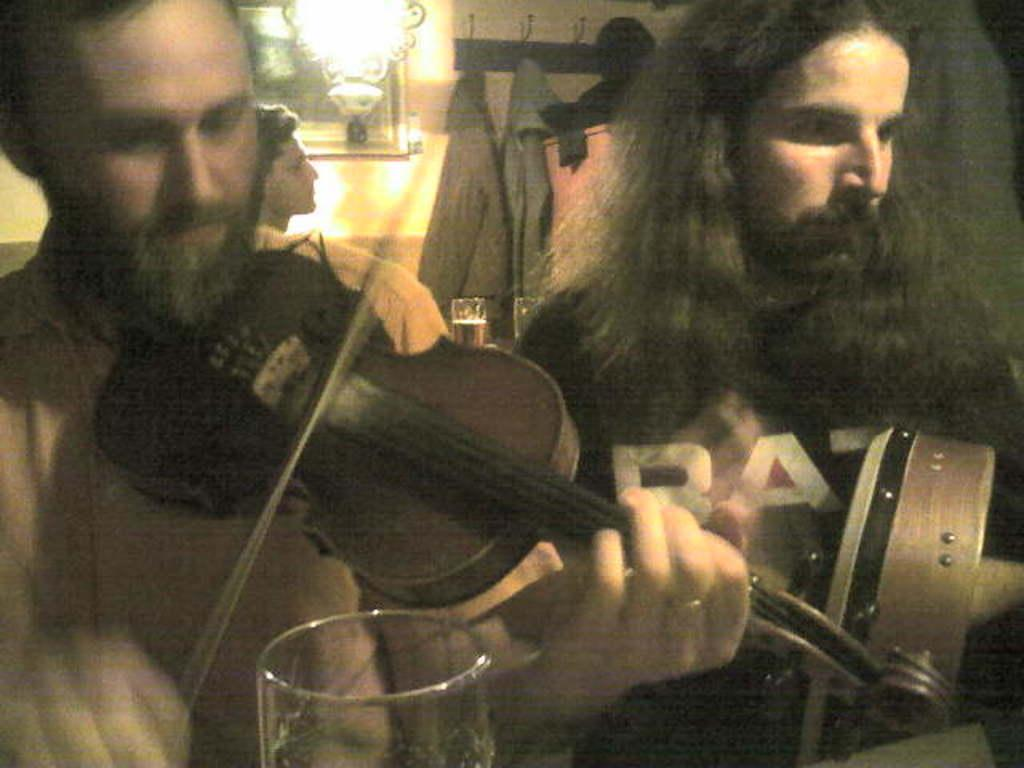How many people are present in the image? There are three people in the image. What is one person doing in the image? One person is playing a violin. What can be seen on the wall in the background? There is a frame attached to a wall in the background. What object is visible in the background that is not related to the people or the wall? A glass is visible in the background. Can you see a snail crawling on the violin in the image? No, there is no snail present in the image. 